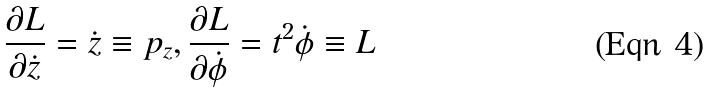Convert formula to latex. <formula><loc_0><loc_0><loc_500><loc_500>\frac { \partial L } { \partial \dot { z } } = \dot { z } \equiv p _ { z } , \frac { \partial L } { \partial { \dot { \phi } } } = t ^ { 2 } \dot { \phi } \equiv L</formula> 